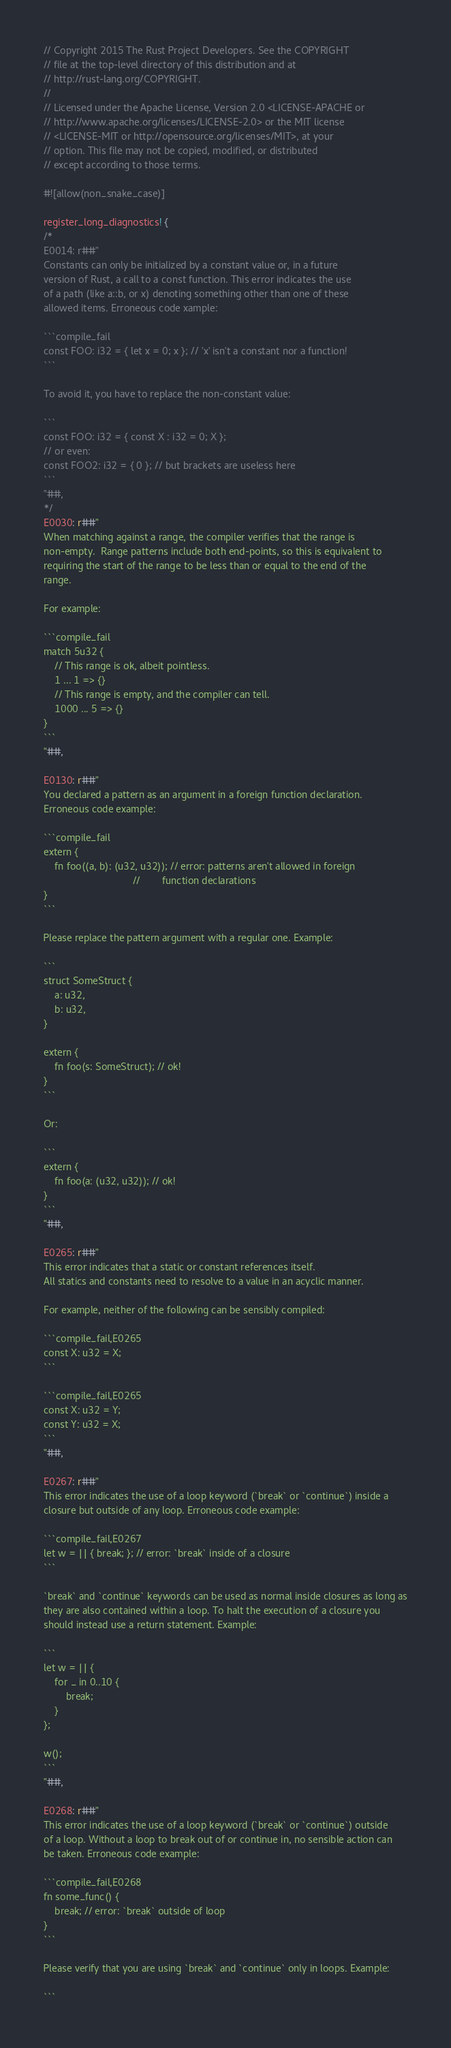<code> <loc_0><loc_0><loc_500><loc_500><_Rust_>// Copyright 2015 The Rust Project Developers. See the COPYRIGHT
// file at the top-level directory of this distribution and at
// http://rust-lang.org/COPYRIGHT.
//
// Licensed under the Apache License, Version 2.0 <LICENSE-APACHE or
// http://www.apache.org/licenses/LICENSE-2.0> or the MIT license
// <LICENSE-MIT or http://opensource.org/licenses/MIT>, at your
// option. This file may not be copied, modified, or distributed
// except according to those terms.

#![allow(non_snake_case)]

register_long_diagnostics! {
/*
E0014: r##"
Constants can only be initialized by a constant value or, in a future
version of Rust, a call to a const function. This error indicates the use
of a path (like a::b, or x) denoting something other than one of these
allowed items. Erroneous code xample:

```compile_fail
const FOO: i32 = { let x = 0; x }; // 'x' isn't a constant nor a function!
```

To avoid it, you have to replace the non-constant value:

```
const FOO: i32 = { const X : i32 = 0; X };
// or even:
const FOO2: i32 = { 0 }; // but brackets are useless here
```
"##,
*/
E0030: r##"
When matching against a range, the compiler verifies that the range is
non-empty.  Range patterns include both end-points, so this is equivalent to
requiring the start of the range to be less than or equal to the end of the
range.

For example:

```compile_fail
match 5u32 {
    // This range is ok, albeit pointless.
    1 ... 1 => {}
    // This range is empty, and the compiler can tell.
    1000 ... 5 => {}
}
```
"##,

E0130: r##"
You declared a pattern as an argument in a foreign function declaration.
Erroneous code example:

```compile_fail
extern {
    fn foo((a, b): (u32, u32)); // error: patterns aren't allowed in foreign
                                //        function declarations
}
```

Please replace the pattern argument with a regular one. Example:

```
struct SomeStruct {
    a: u32,
    b: u32,
}

extern {
    fn foo(s: SomeStruct); // ok!
}
```

Or:

```
extern {
    fn foo(a: (u32, u32)); // ok!
}
```
"##,

E0265: r##"
This error indicates that a static or constant references itself.
All statics and constants need to resolve to a value in an acyclic manner.

For example, neither of the following can be sensibly compiled:

```compile_fail,E0265
const X: u32 = X;
```

```compile_fail,E0265
const X: u32 = Y;
const Y: u32 = X;
```
"##,

E0267: r##"
This error indicates the use of a loop keyword (`break` or `continue`) inside a
closure but outside of any loop. Erroneous code example:

```compile_fail,E0267
let w = || { break; }; // error: `break` inside of a closure
```

`break` and `continue` keywords can be used as normal inside closures as long as
they are also contained within a loop. To halt the execution of a closure you
should instead use a return statement. Example:

```
let w = || {
    for _ in 0..10 {
        break;
    }
};

w();
```
"##,

E0268: r##"
This error indicates the use of a loop keyword (`break` or `continue`) outside
of a loop. Without a loop to break out of or continue in, no sensible action can
be taken. Erroneous code example:

```compile_fail,E0268
fn some_func() {
    break; // error: `break` outside of loop
}
```

Please verify that you are using `break` and `continue` only in loops. Example:

```</code> 